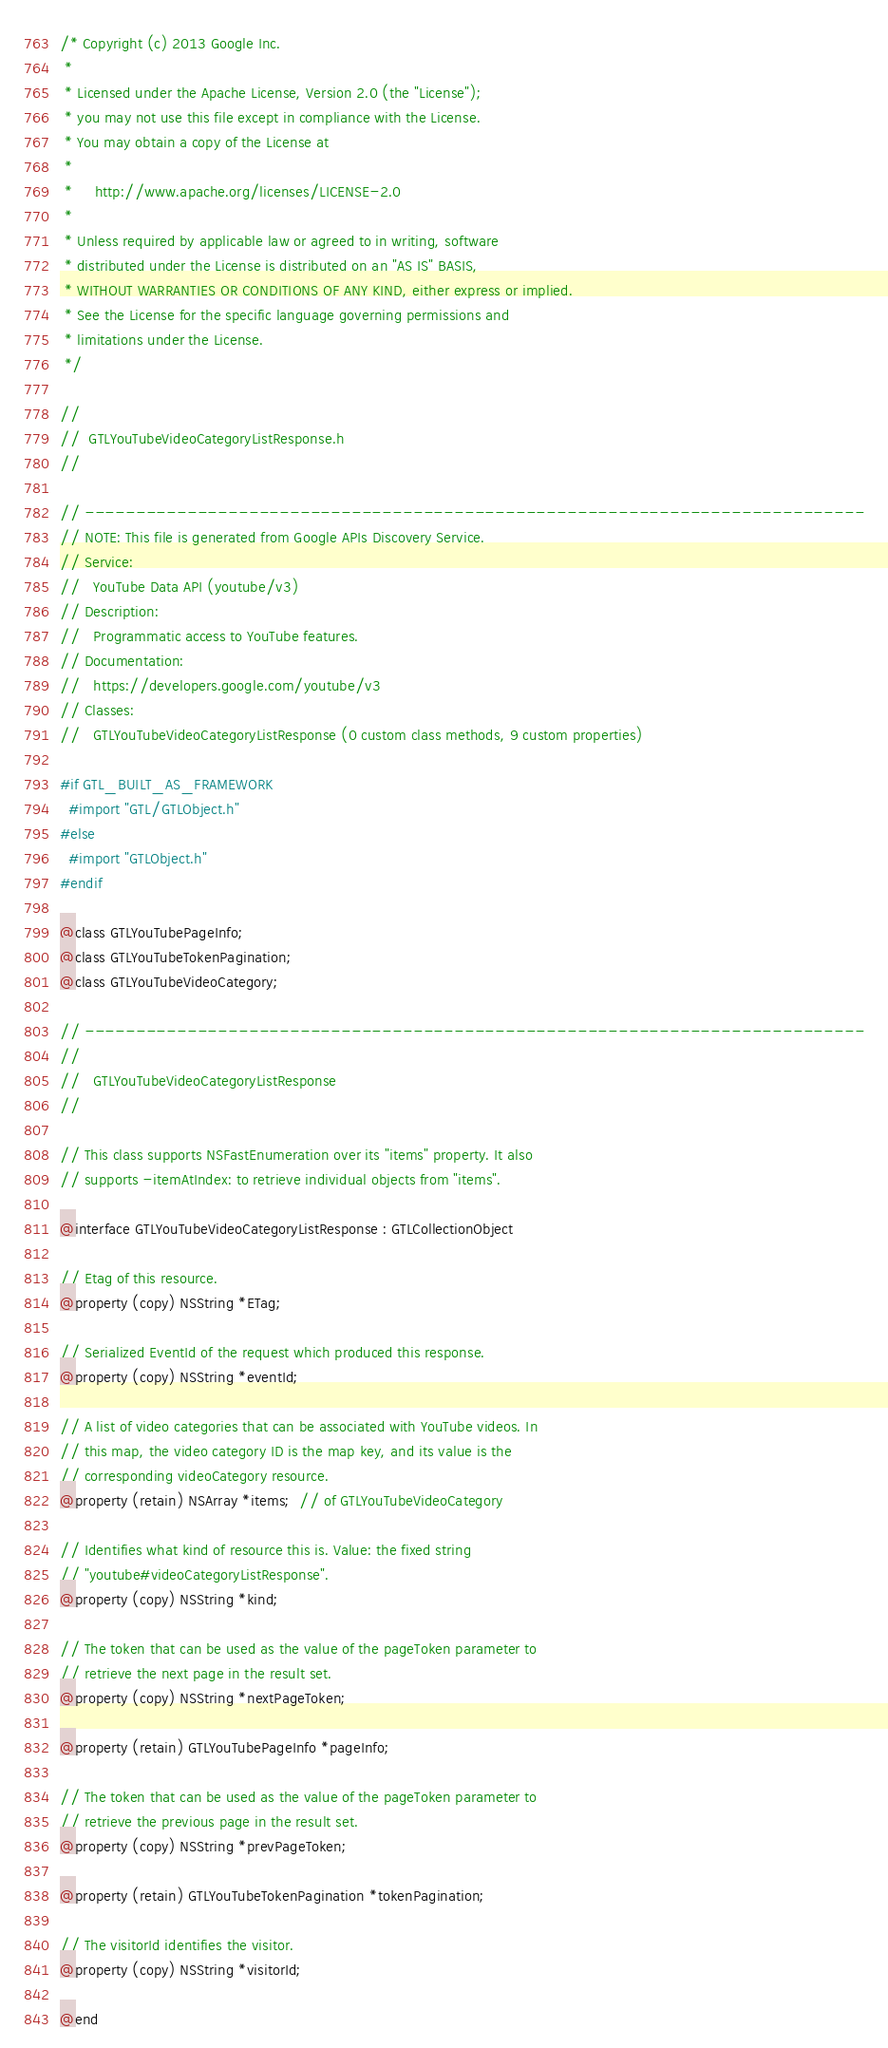<code> <loc_0><loc_0><loc_500><loc_500><_C_>/* Copyright (c) 2013 Google Inc.
 *
 * Licensed under the Apache License, Version 2.0 (the "License");
 * you may not use this file except in compliance with the License.
 * You may obtain a copy of the License at
 *
 *     http://www.apache.org/licenses/LICENSE-2.0
 *
 * Unless required by applicable law or agreed to in writing, software
 * distributed under the License is distributed on an "AS IS" BASIS,
 * WITHOUT WARRANTIES OR CONDITIONS OF ANY KIND, either express or implied.
 * See the License for the specific language governing permissions and
 * limitations under the License.
 */

//
//  GTLYouTubeVideoCategoryListResponse.h
//

// ----------------------------------------------------------------------------
// NOTE: This file is generated from Google APIs Discovery Service.
// Service:
//   YouTube Data API (youtube/v3)
// Description:
//   Programmatic access to YouTube features.
// Documentation:
//   https://developers.google.com/youtube/v3
// Classes:
//   GTLYouTubeVideoCategoryListResponse (0 custom class methods, 9 custom properties)

#if GTL_BUILT_AS_FRAMEWORK
  #import "GTL/GTLObject.h"
#else
  #import "GTLObject.h"
#endif

@class GTLYouTubePageInfo;
@class GTLYouTubeTokenPagination;
@class GTLYouTubeVideoCategory;

// ----------------------------------------------------------------------------
//
//   GTLYouTubeVideoCategoryListResponse
//

// This class supports NSFastEnumeration over its "items" property. It also
// supports -itemAtIndex: to retrieve individual objects from "items".

@interface GTLYouTubeVideoCategoryListResponse : GTLCollectionObject

// Etag of this resource.
@property (copy) NSString *ETag;

// Serialized EventId of the request which produced this response.
@property (copy) NSString *eventId;

// A list of video categories that can be associated with YouTube videos. In
// this map, the video category ID is the map key, and its value is the
// corresponding videoCategory resource.
@property (retain) NSArray *items;  // of GTLYouTubeVideoCategory

// Identifies what kind of resource this is. Value: the fixed string
// "youtube#videoCategoryListResponse".
@property (copy) NSString *kind;

// The token that can be used as the value of the pageToken parameter to
// retrieve the next page in the result set.
@property (copy) NSString *nextPageToken;

@property (retain) GTLYouTubePageInfo *pageInfo;

// The token that can be used as the value of the pageToken parameter to
// retrieve the previous page in the result set.
@property (copy) NSString *prevPageToken;

@property (retain) GTLYouTubeTokenPagination *tokenPagination;

// The visitorId identifies the visitor.
@property (copy) NSString *visitorId;

@end
</code> 